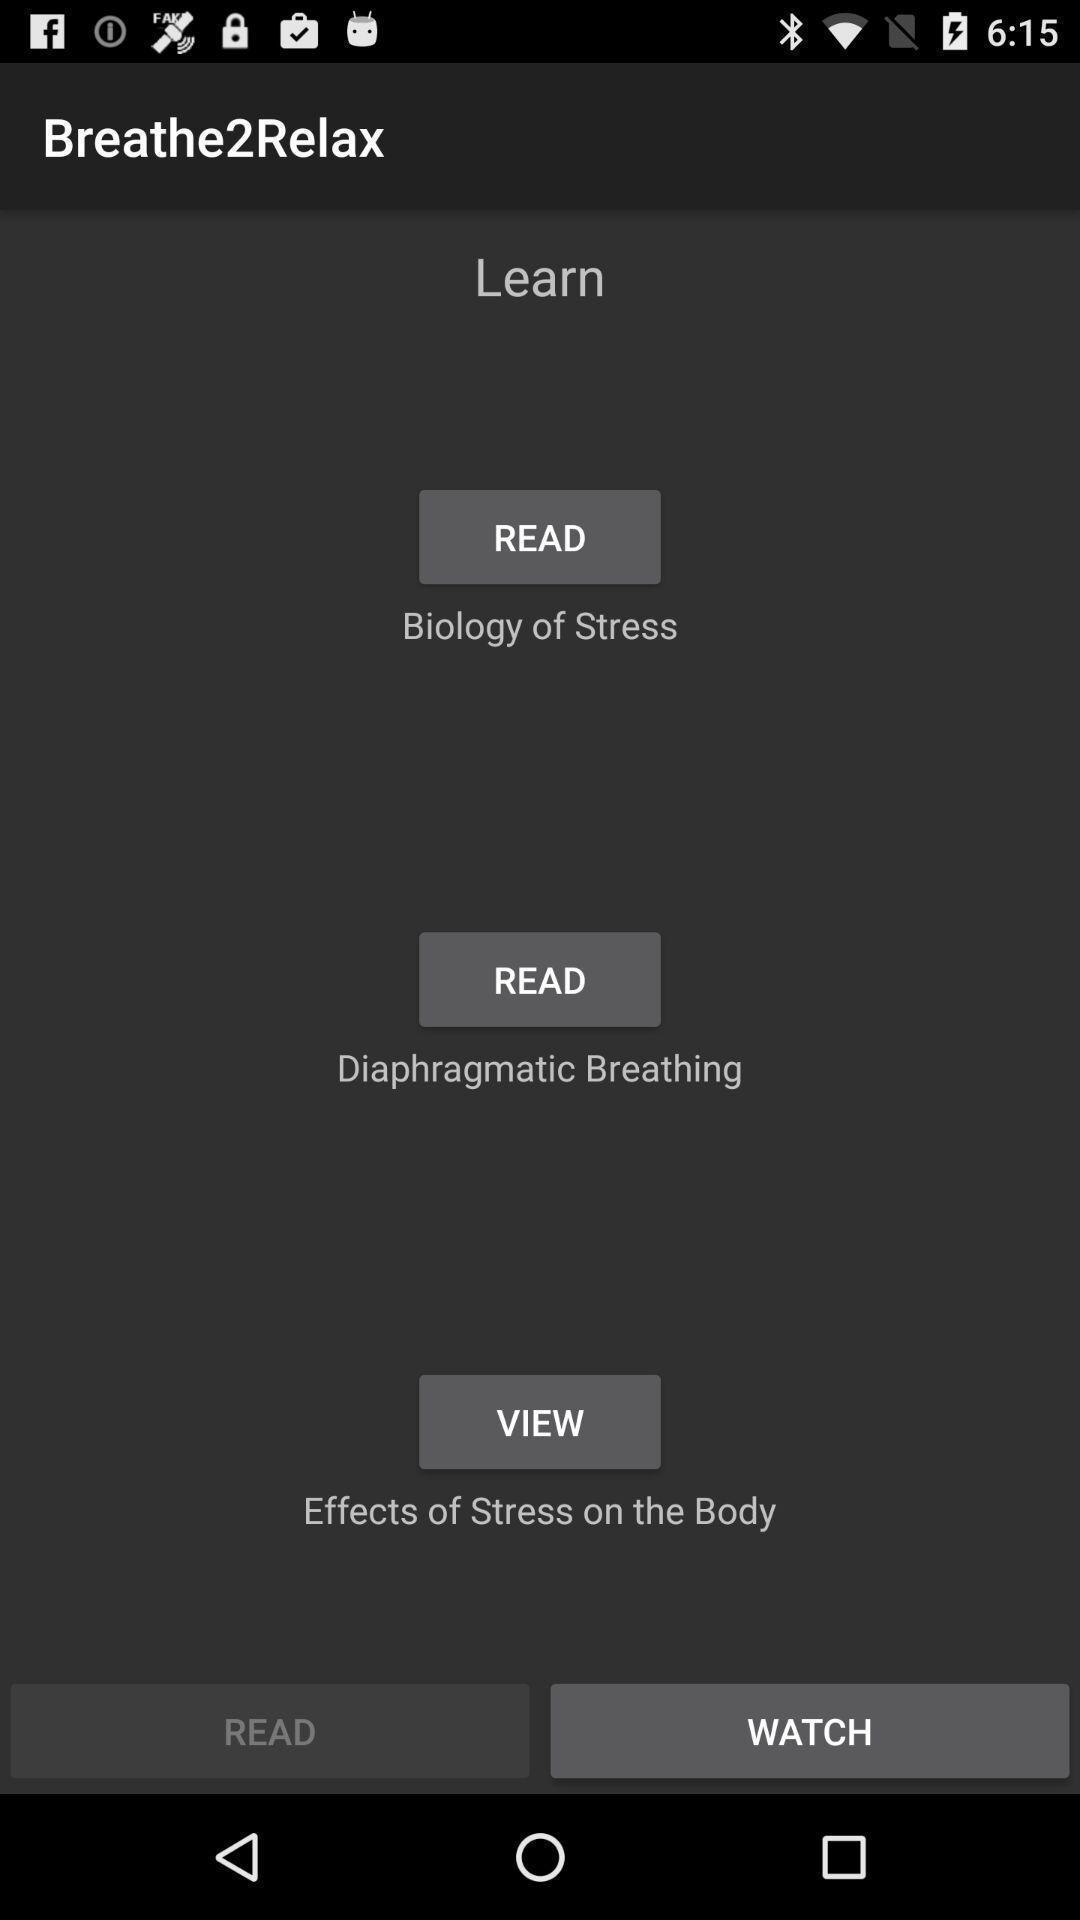Please provide a description for this image. Screen showing information to be read of a health app. 